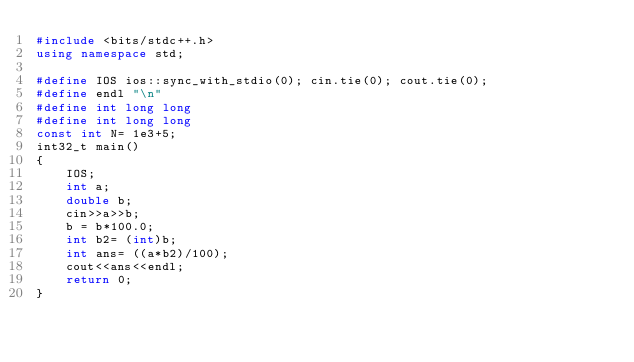Convert code to text. <code><loc_0><loc_0><loc_500><loc_500><_C++_>#include <bits/stdc++.h>
using namespace std;
 
#define IOS ios::sync_with_stdio(0); cin.tie(0); cout.tie(0);
#define endl "\n"
#define int long long
#define int long long
const int N= 1e3+5;
int32_t main()
{
    IOS;
    int a;
    double b;
    cin>>a>>b;
    b = b*100.0;
    int b2= (int)b;
    int ans= ((a*b2)/100);
    cout<<ans<<endl;
    return 0;
}


</code> 